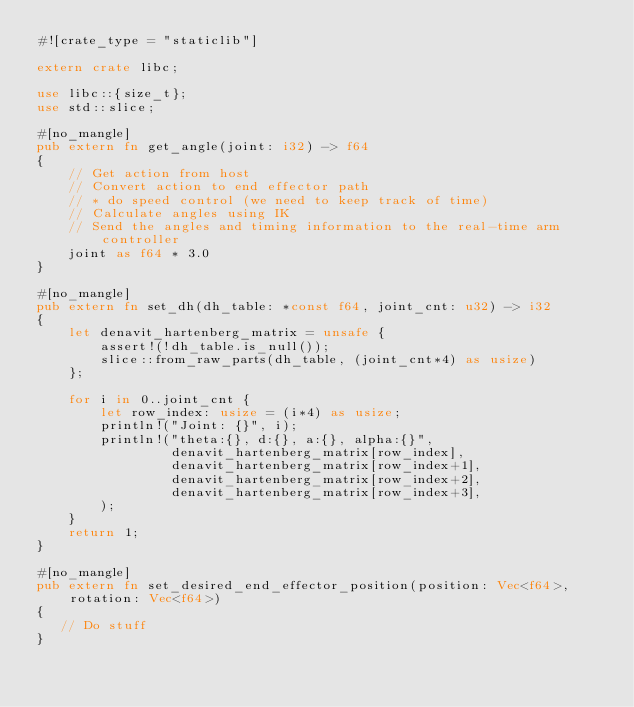<code> <loc_0><loc_0><loc_500><loc_500><_Rust_>#![crate_type = "staticlib"]

extern crate libc;

use libc::{size_t};
use std::slice;

#[no_mangle]
pub extern fn get_angle(joint: i32) -> f64
{
    // Get action from host
    // Convert action to end effector path
    // * do speed control (we need to keep track of time)
    // Calculate angles using IK
    // Send the angles and timing information to the real-time arm controller
    joint as f64 * 3.0
}

#[no_mangle]
pub extern fn set_dh(dh_table: *const f64, joint_cnt: u32) -> i32
{
    let denavit_hartenberg_matrix = unsafe {
        assert!(!dh_table.is_null());
        slice::from_raw_parts(dh_table, (joint_cnt*4) as usize)
    };

    for i in 0..joint_cnt {
        let row_index: usize = (i*4) as usize;
        println!("Joint: {}", i);
        println!("theta:{}, d:{}, a:{}, alpha:{}",
                 denavit_hartenberg_matrix[row_index],
                 denavit_hartenberg_matrix[row_index+1],
                 denavit_hartenberg_matrix[row_index+2],
                 denavit_hartenberg_matrix[row_index+3],
        );
    }
    return 1;
}

#[no_mangle]
pub extern fn set_desired_end_effector_position(position: Vec<f64>, rotation: Vec<f64>)
{
   // Do stuff
}
</code> 